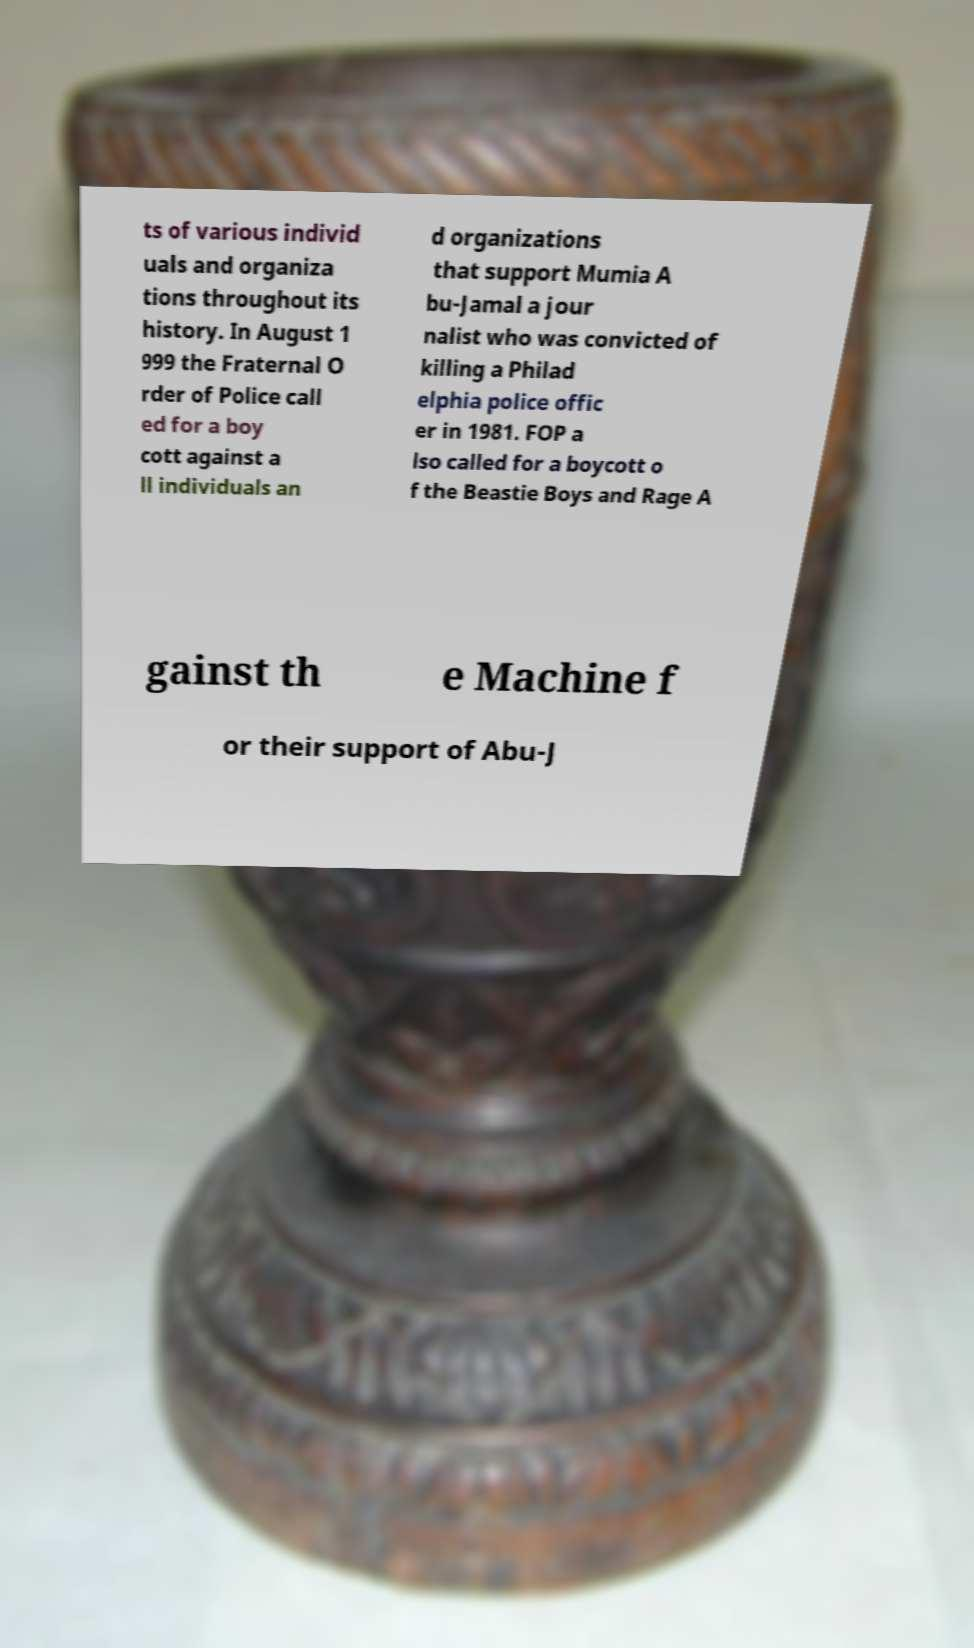Could you extract and type out the text from this image? ts of various individ uals and organiza tions throughout its history. In August 1 999 the Fraternal O rder of Police call ed for a boy cott against a ll individuals an d organizations that support Mumia A bu-Jamal a jour nalist who was convicted of killing a Philad elphia police offic er in 1981. FOP a lso called for a boycott o f the Beastie Boys and Rage A gainst th e Machine f or their support of Abu-J 